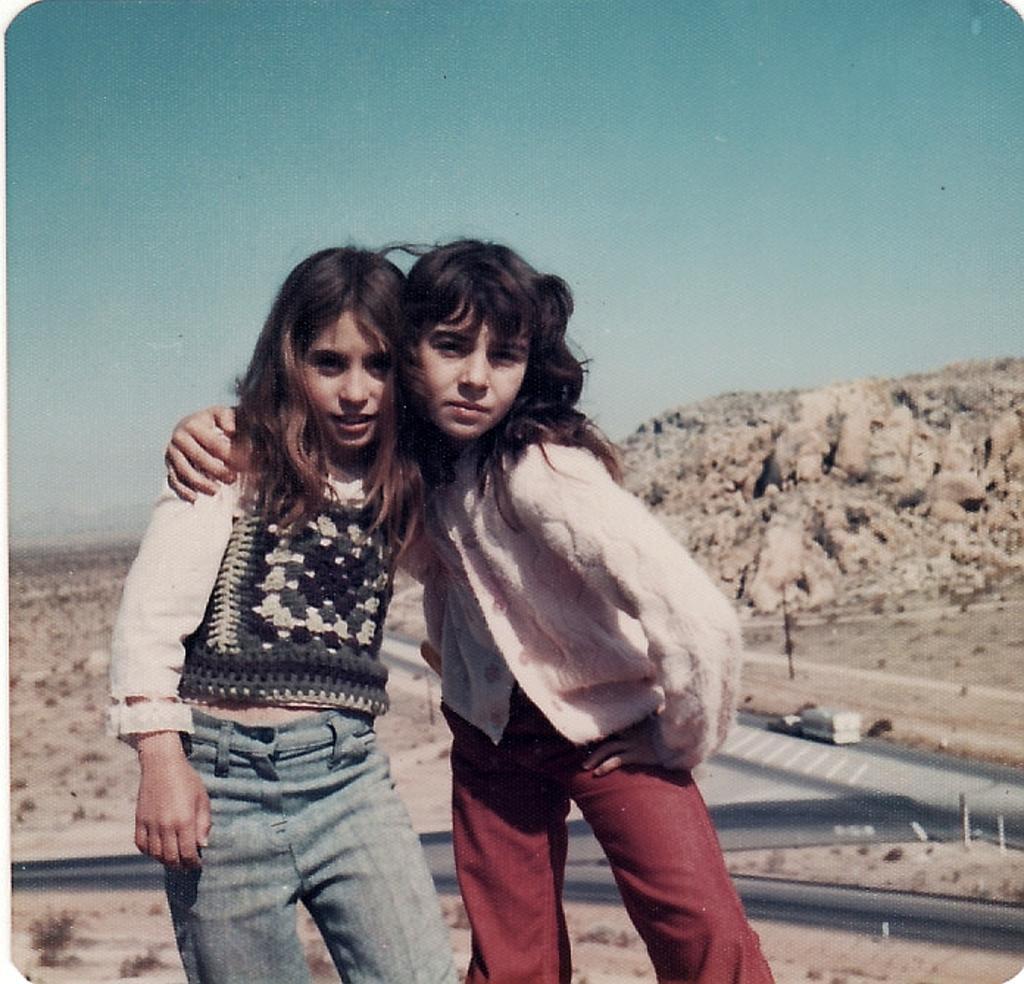Can you describe this image briefly? In this image we can see two children standing. On the backside we can see a vehicle on the road, the hills, some plants and the sky which looks cloudy. 